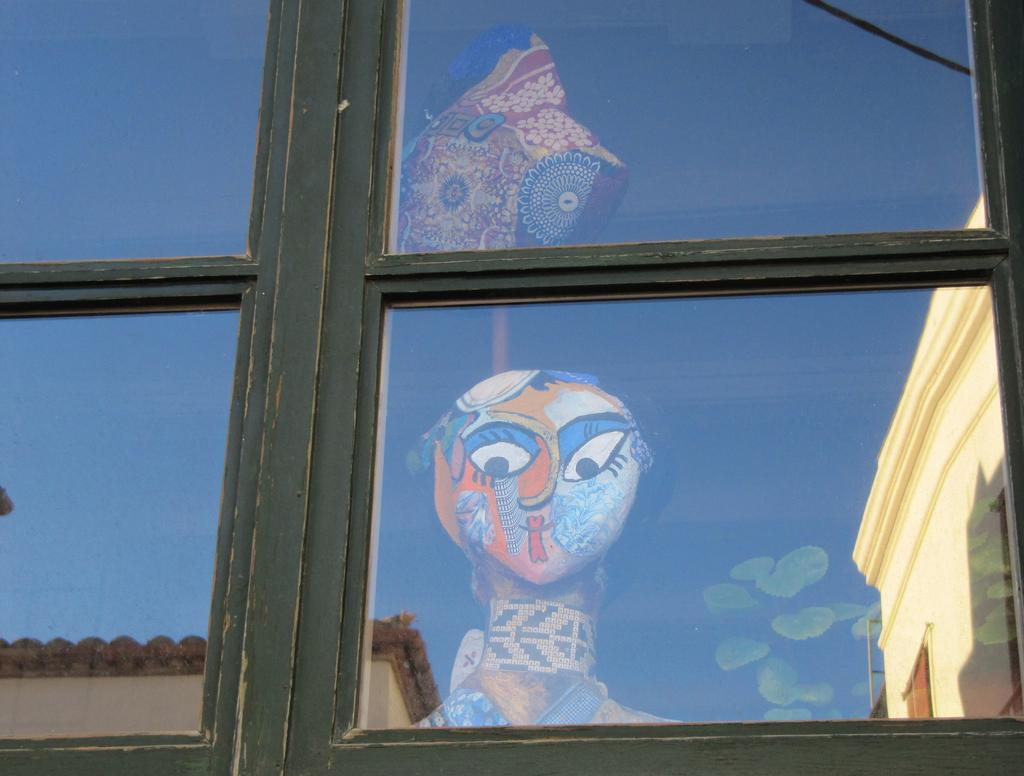What type of structure is visible in the image? There is a glass window in the image. What can be seen through the glass window? A building and a toy are visible through the glass window. Are there any other structures visible in the image? Yes, there is another building on the right side of the glass window. What else is present on the right side of the glass window? A plant is present on the right side of the glass window. Where is the toothbrush located in the image? There is no toothbrush present in the image. What type of doll can be seen interacting with the plant on the right side of the glass window? There is no doll present in the image; only a building, a toy, and a plant are visible. 